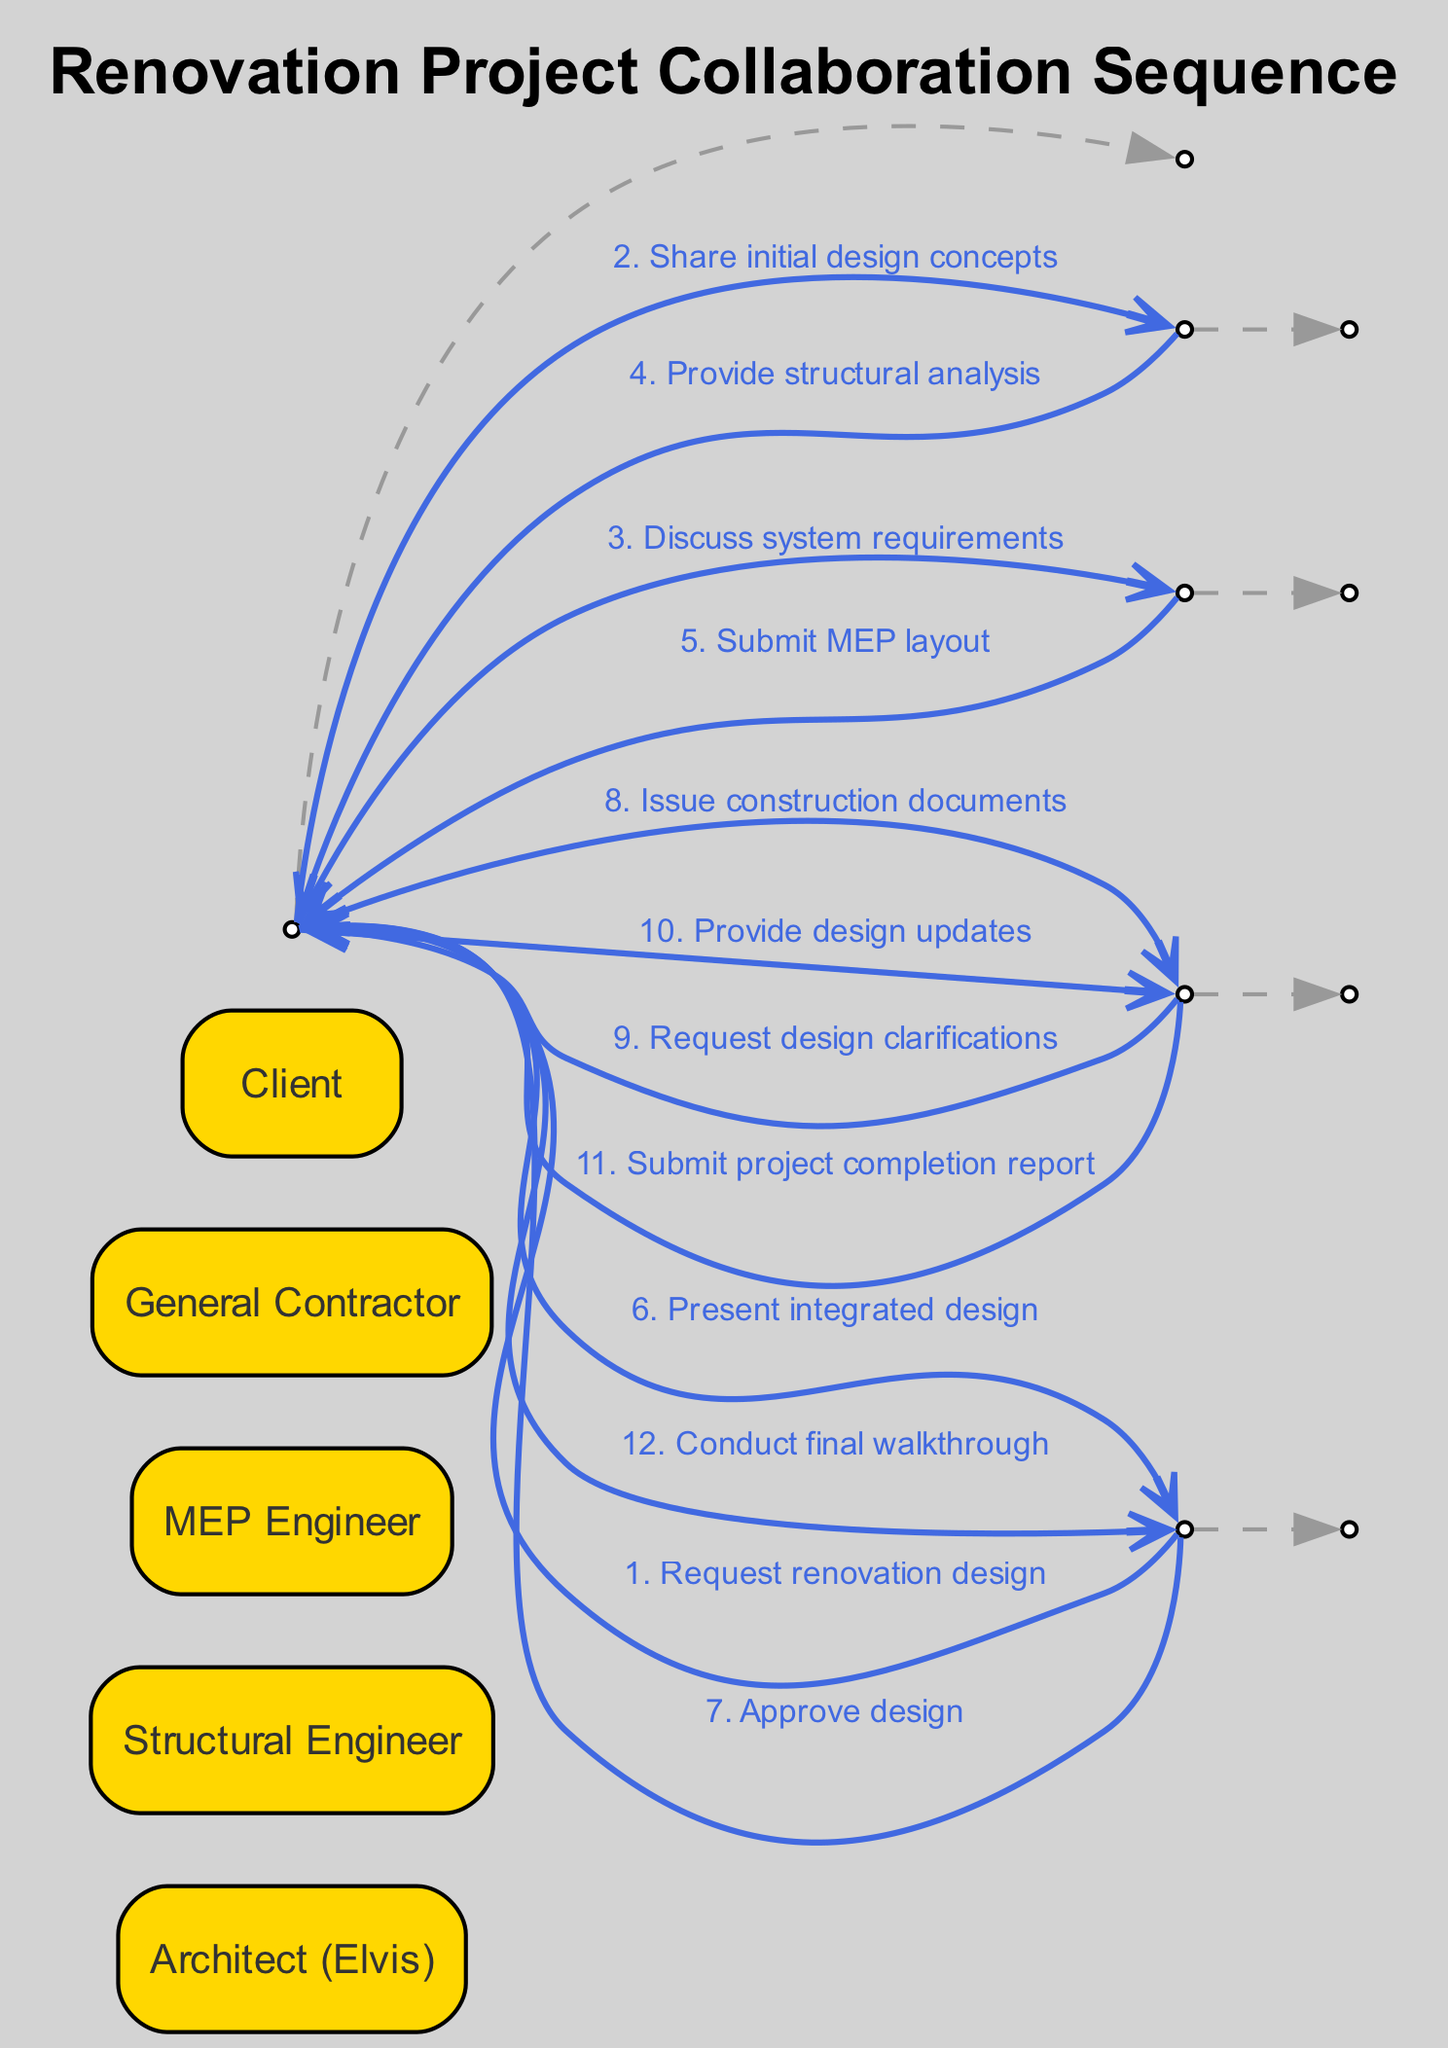What is the first message sent in the sequence? The first message in the sequence starts from the Client, requesting a renovation design from the Architect (Elvis). This is confirmed by the first interaction in the sequence.
Answer: Request renovation design How many actors are involved in the sequence? I count five distinct actors in the diagram: Architect (Elvis), Structural Engineer, MEP Engineer, General Contractor, and Client. This is based on the "actors" list provided.
Answer: 5 What message is presented to the Client after the design is integrated? After the Architect (Elvis) receives input from the engineers, the next step is to present the integrated design to the Client as indicated in the sequence.
Answer: Present integrated design Who approves the final design? The Client is responsible for approving the final design after the Architect (Elvis) presents it, as shown in the sequence where the Client sends an approval message to the Architect (Elvis).
Answer: Client What does the General Contractor request after receiving construction documents? After receiving the construction documents from the Architect (Elvis), the General Contractor reaches out to request design clarifications, as outlined in the sequence.
Answer: Request design clarifications How many messages does the Architect (Elvis) send throughout the interactions? The Architect (Elvis) sends a total of five messages: one to the Structural Engineer, one to the MEP Engineer, one to the Client, one to the General Contractor, and one for the final walkthrough. I counted each distinct message sent by the Architect.
Answer: 5 Which engineer submits the MEP layout? The MEP Engineer is responsible for submitting the MEP layout to the Architect (Elvis), as indicated in the specific interaction of the sequence.
Answer: MEP Engineer What is the last action taken by the Architect (Elvis) in the sequence? The last action taken is conducting a final walkthrough with the Client after the General Contractor submits the project completion report, which is the final interaction of the sequence.
Answer: Conduct final walkthrough 